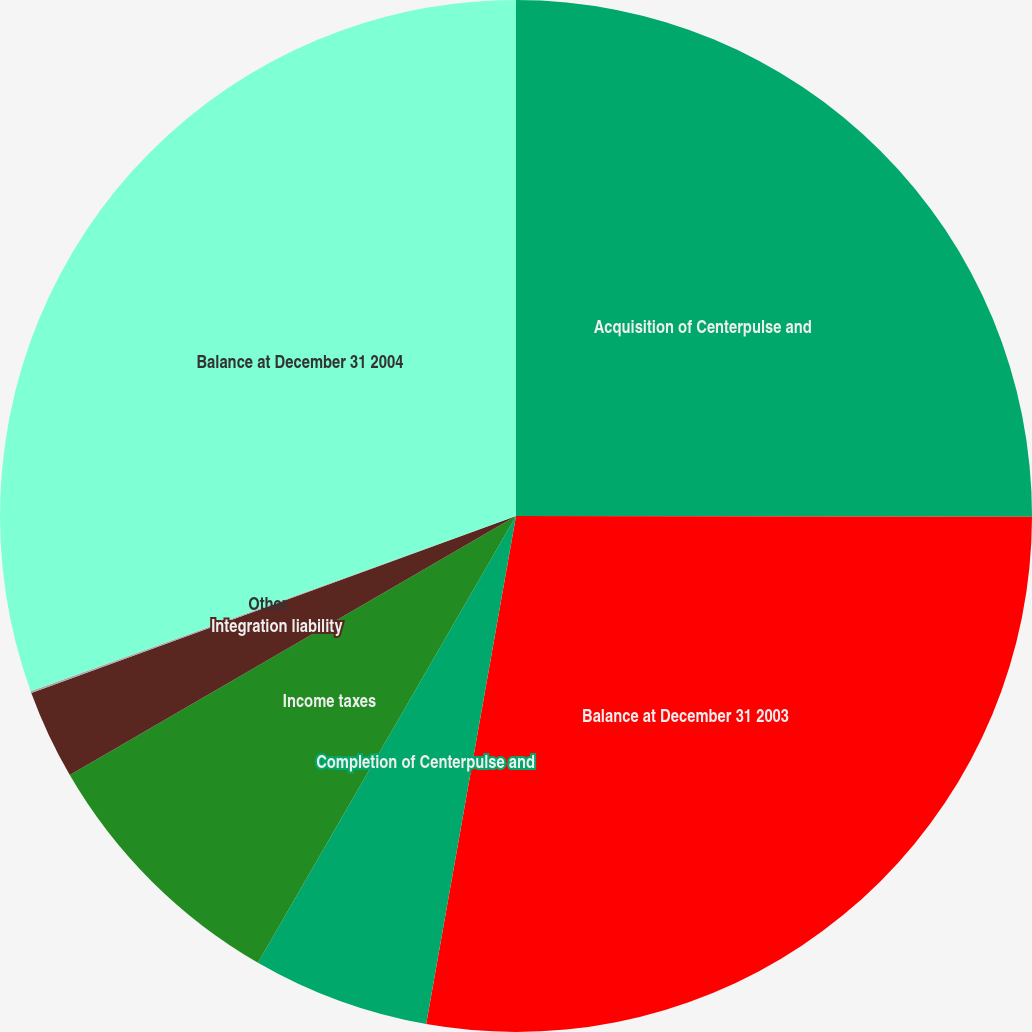<chart> <loc_0><loc_0><loc_500><loc_500><pie_chart><fcel>Acquisition of Centerpulse and<fcel>Balance at December 31 2003<fcel>Completion of Centerpulse and<fcel>Income taxes<fcel>Integration liability<fcel>Other<fcel>Balance at December 31 2004<nl><fcel>25.02%<fcel>27.76%<fcel>5.55%<fcel>8.29%<fcel>2.8%<fcel>0.06%<fcel>30.51%<nl></chart> 